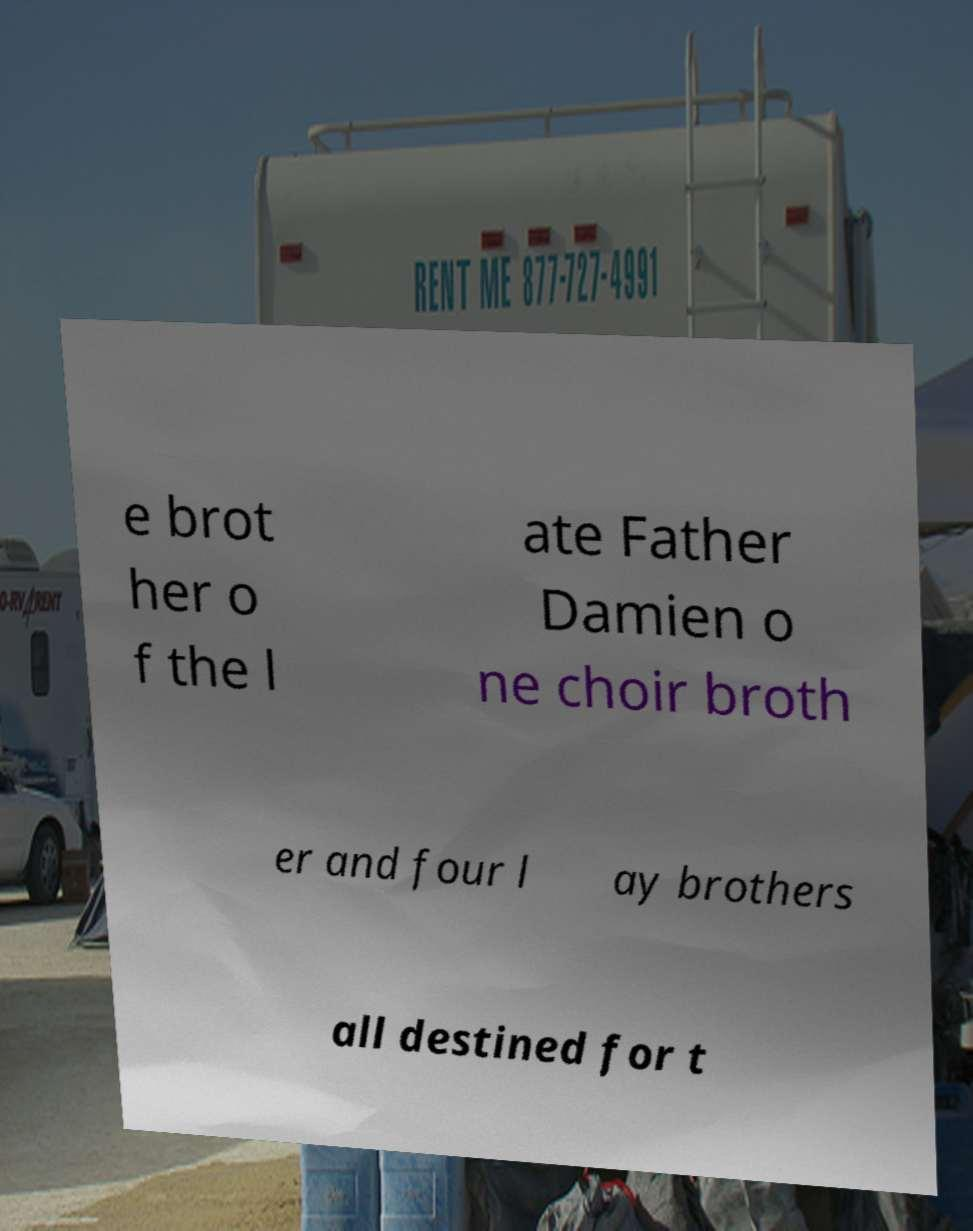For documentation purposes, I need the text within this image transcribed. Could you provide that? e brot her o f the l ate Father Damien o ne choir broth er and four l ay brothers all destined for t 